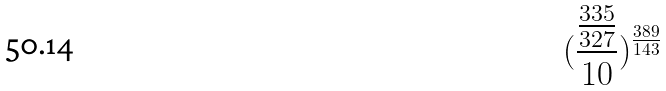Convert formula to latex. <formula><loc_0><loc_0><loc_500><loc_500>( \frac { \frac { 3 3 5 } { 3 2 7 } } { 1 0 } ) ^ { \frac { 3 8 9 } { 1 4 3 } }</formula> 